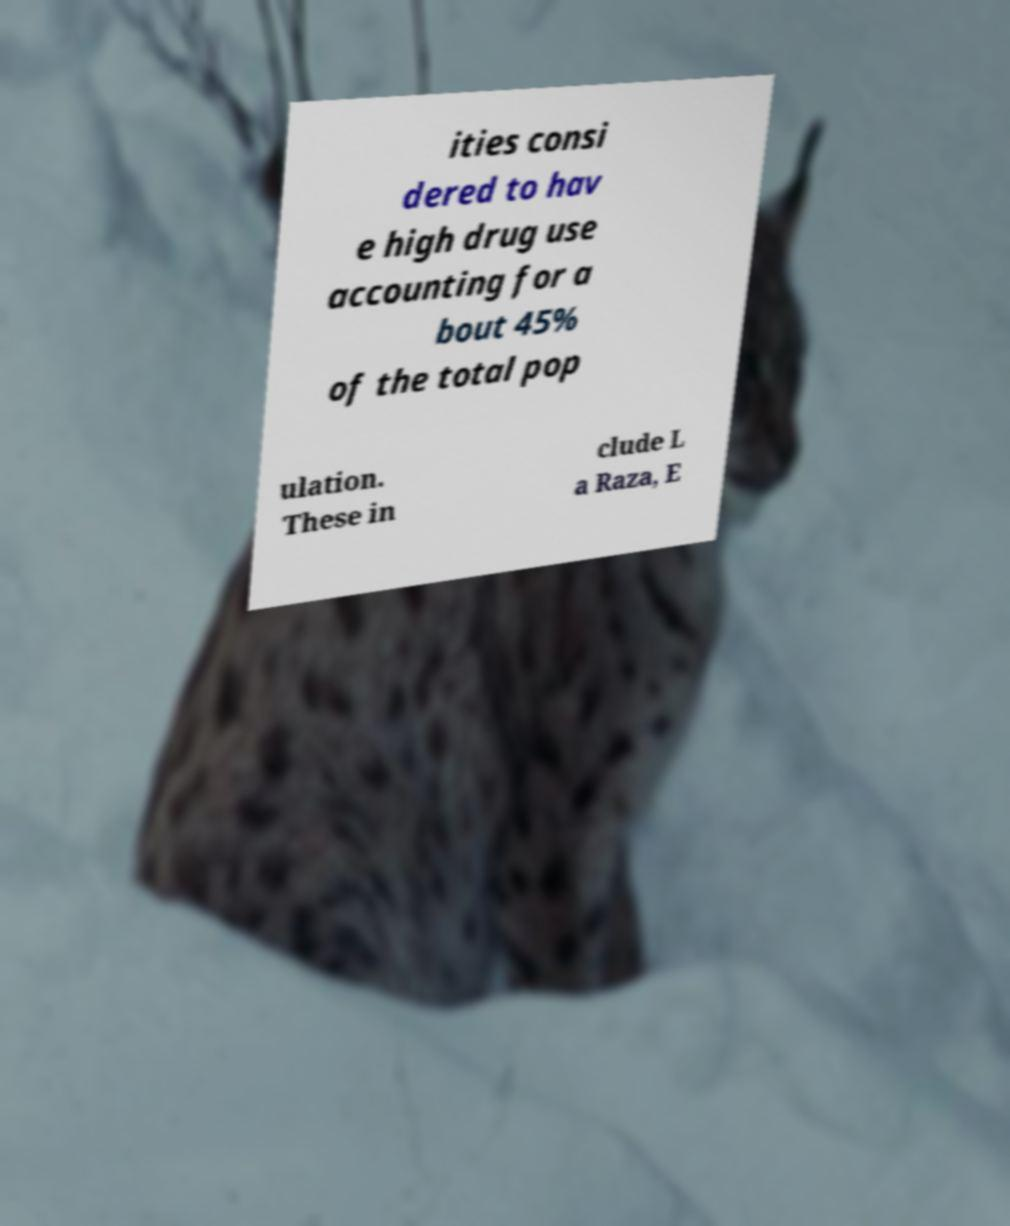There's text embedded in this image that I need extracted. Can you transcribe it verbatim? ities consi dered to hav e high drug use accounting for a bout 45% of the total pop ulation. These in clude L a Raza, E 